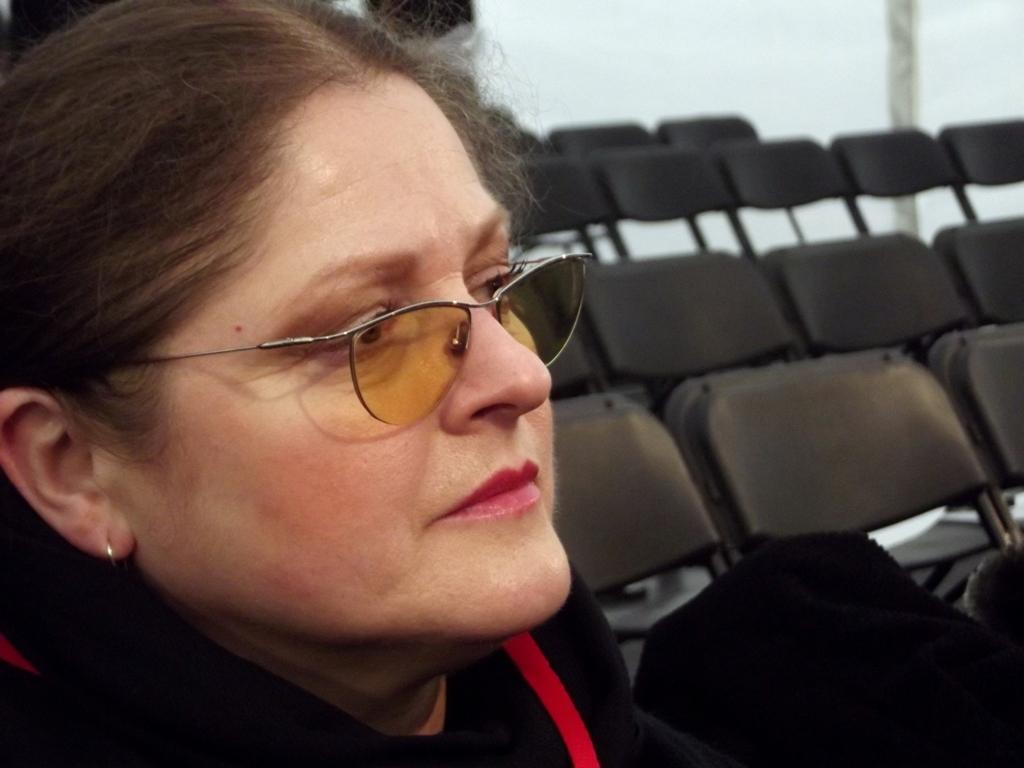Describe this image in one or two sentences. In this image, we can see a lady wearing glasses and in the background, there are chairs. 